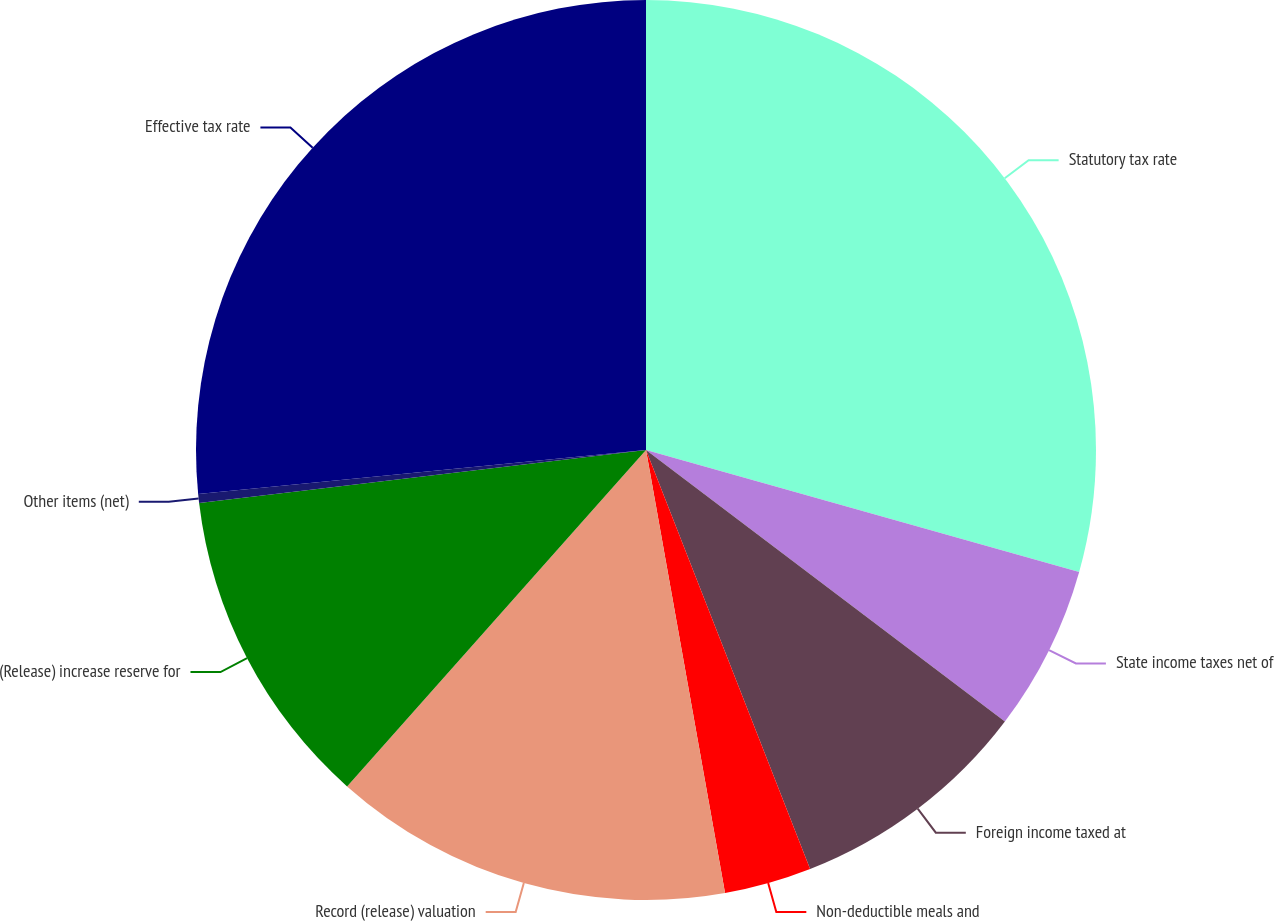<chart> <loc_0><loc_0><loc_500><loc_500><pie_chart><fcel>Statutory tax rate<fcel>State income taxes net of<fcel>Foreign income taxed at<fcel>Non-deductible meals and<fcel>Record (release) valuation<fcel>(Release) increase reserve for<fcel>Other items (net)<fcel>Effective tax rate<nl><fcel>29.36%<fcel>5.94%<fcel>8.75%<fcel>3.13%<fcel>14.37%<fcel>11.56%<fcel>0.32%<fcel>26.55%<nl></chart> 